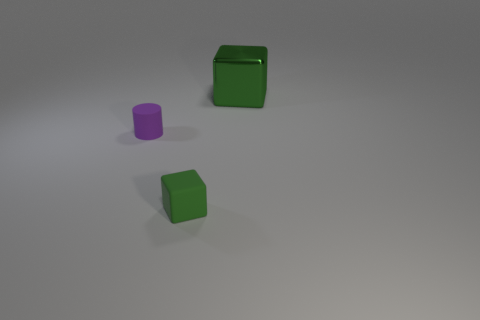Add 3 purple rubber cylinders. How many objects exist? 6 Subtract all cylinders. How many objects are left? 2 Subtract 0 brown spheres. How many objects are left? 3 Subtract all big shiny objects. Subtract all green metal cubes. How many objects are left? 1 Add 1 metallic cubes. How many metallic cubes are left? 2 Add 1 big green cubes. How many big green cubes exist? 2 